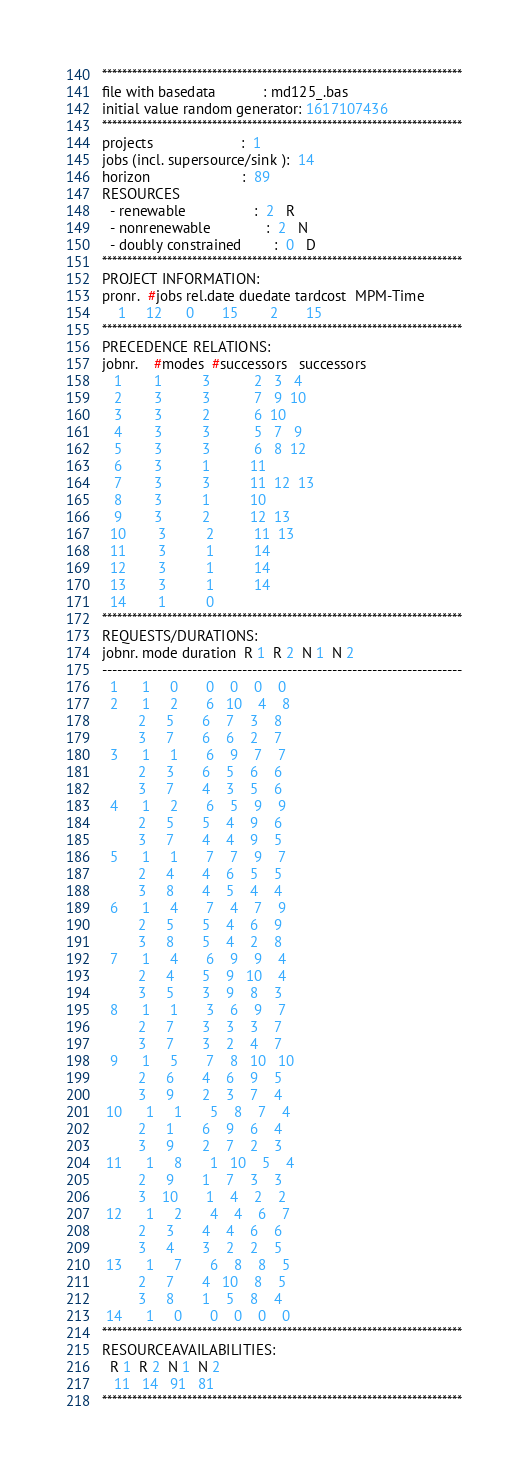Convert code to text. <code><loc_0><loc_0><loc_500><loc_500><_ObjectiveC_>************************************************************************
file with basedata            : md125_.bas
initial value random generator: 1617107436
************************************************************************
projects                      :  1
jobs (incl. supersource/sink ):  14
horizon                       :  89
RESOURCES
  - renewable                 :  2   R
  - nonrenewable              :  2   N
  - doubly constrained        :  0   D
************************************************************************
PROJECT INFORMATION:
pronr.  #jobs rel.date duedate tardcost  MPM-Time
    1     12      0       15        2       15
************************************************************************
PRECEDENCE RELATIONS:
jobnr.    #modes  #successors   successors
   1        1          3           2   3   4
   2        3          3           7   9  10
   3        3          2           6  10
   4        3          3           5   7   9
   5        3          3           6   8  12
   6        3          1          11
   7        3          3          11  12  13
   8        3          1          10
   9        3          2          12  13
  10        3          2          11  13
  11        3          1          14
  12        3          1          14
  13        3          1          14
  14        1          0        
************************************************************************
REQUESTS/DURATIONS:
jobnr. mode duration  R 1  R 2  N 1  N 2
------------------------------------------------------------------------
  1      1     0       0    0    0    0
  2      1     2       6   10    4    8
         2     5       6    7    3    8
         3     7       6    6    2    7
  3      1     1       6    9    7    7
         2     3       6    5    6    6
         3     7       4    3    5    6
  4      1     2       6    5    9    9
         2     5       5    4    9    6
         3     7       4    4    9    5
  5      1     1       7    7    9    7
         2     4       4    6    5    5
         3     8       4    5    4    4
  6      1     4       7    4    7    9
         2     5       5    4    6    9
         3     8       5    4    2    8
  7      1     4       6    9    9    4
         2     4       5    9   10    4
         3     5       3    9    8    3
  8      1     1       3    6    9    7
         2     7       3    3    3    7
         3     7       3    2    4    7
  9      1     5       7    8   10   10
         2     6       4    6    9    5
         3     9       2    3    7    4
 10      1     1       5    8    7    4
         2     1       6    9    6    4
         3     9       2    7    2    3
 11      1     8       1   10    5    4
         2     9       1    7    3    3
         3    10       1    4    2    2
 12      1     2       4    4    6    7
         2     3       4    4    6    6
         3     4       3    2    2    5
 13      1     7       6    8    8    5
         2     7       4   10    8    5
         3     8       1    5    8    4
 14      1     0       0    0    0    0
************************************************************************
RESOURCEAVAILABILITIES:
  R 1  R 2  N 1  N 2
   11   14   91   81
************************************************************************
</code> 